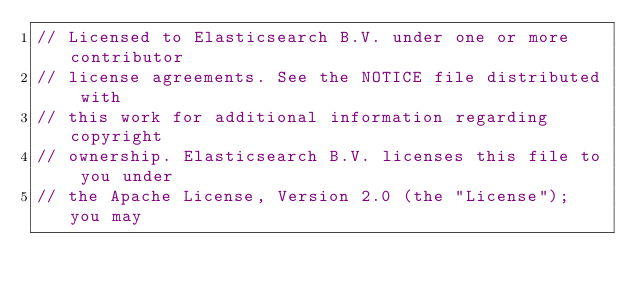Convert code to text. <code><loc_0><loc_0><loc_500><loc_500><_Go_>// Licensed to Elasticsearch B.V. under one or more contributor
// license agreements. See the NOTICE file distributed with
// this work for additional information regarding copyright
// ownership. Elasticsearch B.V. licenses this file to you under
// the Apache License, Version 2.0 (the "License"); you may</code> 